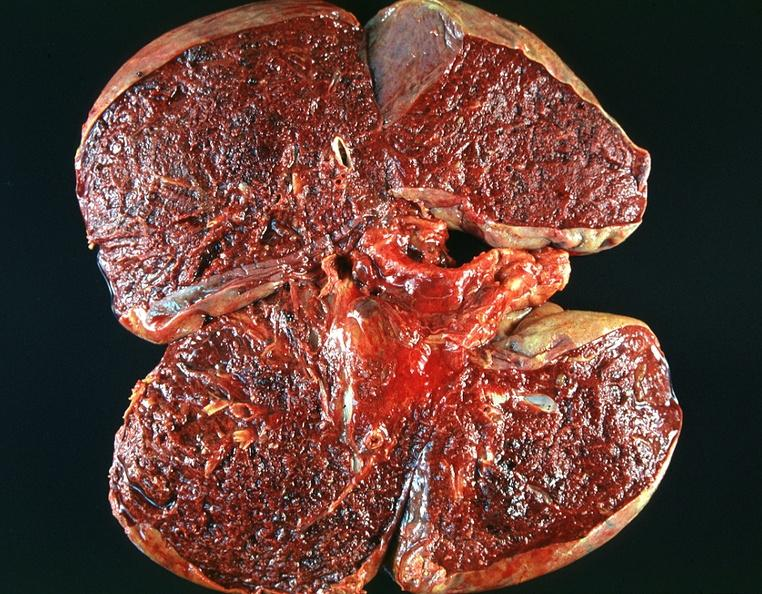s respiratory present?
Answer the question using a single word or phrase. Yes 